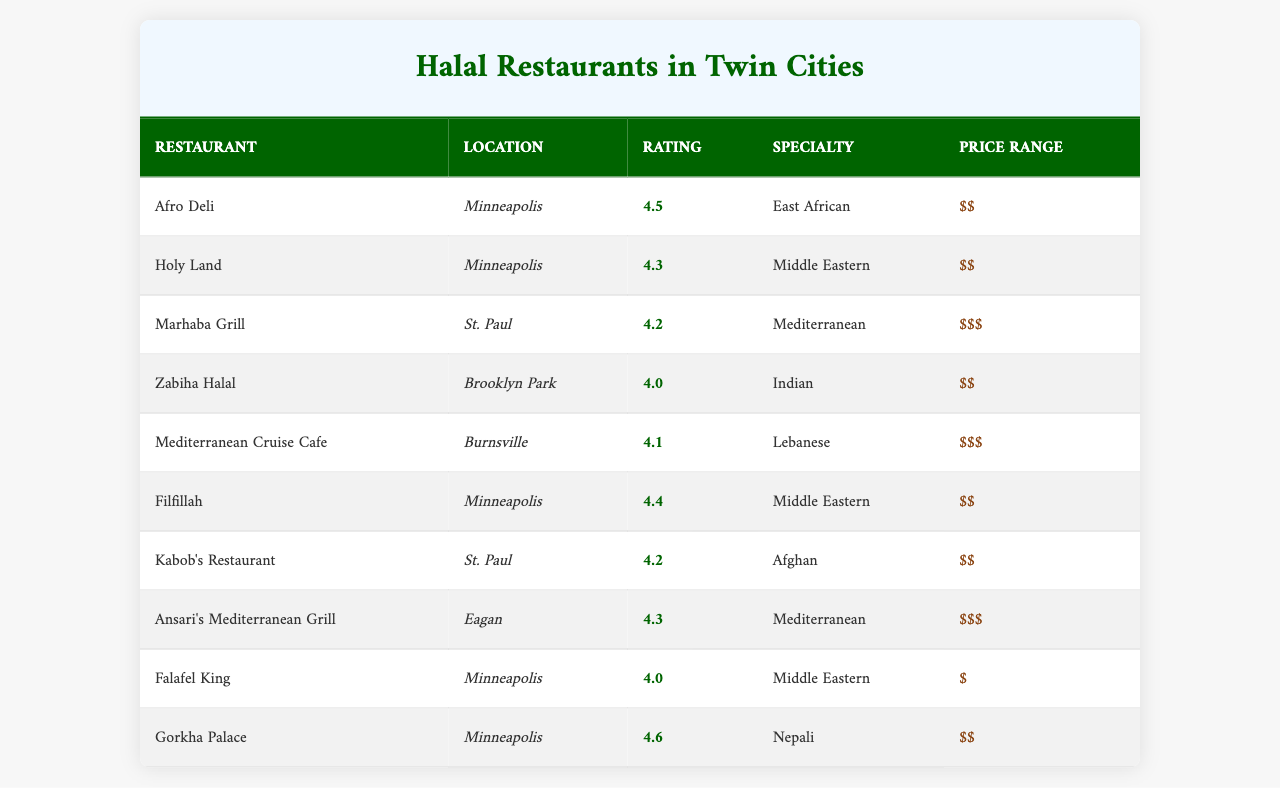What is the highest-rated restaurant in Minneapolis? The table lists restaurants in Minneapolis and their ratings. By examining the ratings for Afro Deli (4.5), Holy Land (4.3), Filfillah (4.4), and Falafel King (4.0), Afro Deli has the highest rating at 4.5.
Answer: Afro Deli How many restaurants have a rating of 4.2 or higher? By reviewing the table, the restaurants with ratings of 4.2 or higher are: Afro Deli (4.5), Filfillah (4.4), Holy Land (4.3), Ansari's Mediterranean Grill (4.3), Marhaba Grill (4.2), and Kabob's Restaurant (4.2). In total, there are 6 such restaurants.
Answer: 6 What restaurant located in St. Paul has the highest rating? In evaluating the St. Paul listings, Marhaba Grill has a rating of 4.2, and Kabob's Restaurant also has a rating of 4.2. Since both restaurants have the same rating, they are tied for the highest.
Answer: Marhaba Grill and Kabob's Restaurant Which restaurant has the lowest price range? The table indicates that the price ranges are as follows: Falafel King ($), Afro Deli ($$), Holy Land ($$), etc. Based on this, Falafel King has the lowest price range of $ (1).
Answer: Falafel King What is the average rating of the restaurants located in Minneapolis? The ratings for Minneapolis restaurants are: Afro Deli (4.5), Holy Land (4.3), Filfillah (4.4), and Falafel King (4.0). Sum these: 4.5 + 4.3 + 4.4 + 4.0 = 17.2. There are 4 restaurants, so the average is 17.2 / 4 = 4.3.
Answer: 4.3 Is there a Nepali Halal restaurant in the Twin Cities? The table lists Gorkha Palace as a Nepali restaurant located in Minneapolis. Thus, there is indeed a Nepali Halal restaurant.
Answer: Yes Which location has the highest-rated restaurant among the listed restaurants? Evaluating the ratings, Gorkha Palace in Minneapolis has the highest rating at 4.6, which is higher than any restaurant in other locations such as St. Paul and Brooklyn Park.
Answer: Minneapolis How many restaurants have a rating of 4.0 or lower? The ratings in the table for restaurants below 4.0 are: Zabiha Halal (4.0) and Falafel King (4.0). Thus, there are 2 restaurants that fit this criterion.
Answer: 2 What is the price range for Kabob's Restaurant? Looking at the table, Kabob's Restaurant is listed at a price range of $$, which corresponds to a price range of 2.
Answer: $$ 